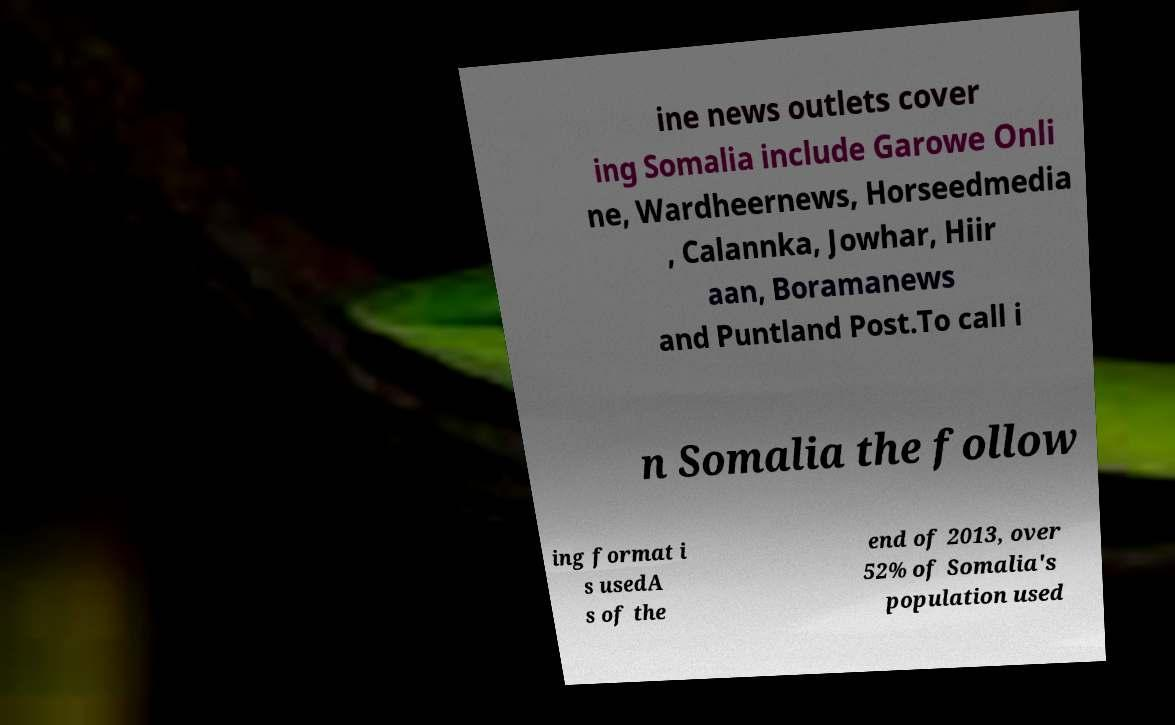Can you accurately transcribe the text from the provided image for me? ine news outlets cover ing Somalia include Garowe Onli ne, Wardheernews, Horseedmedia , Calannka, Jowhar, Hiir aan, Boramanews and Puntland Post.To call i n Somalia the follow ing format i s usedA s of the end of 2013, over 52% of Somalia's population used 